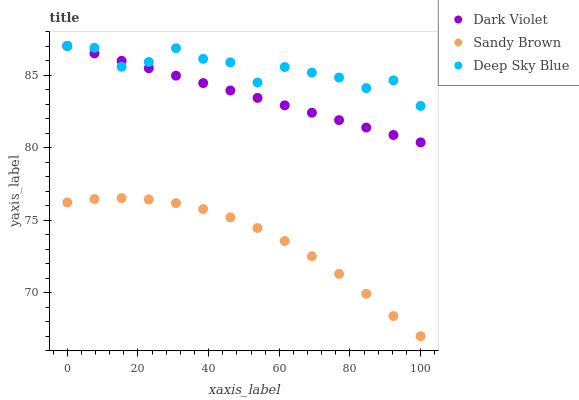Does Sandy Brown have the minimum area under the curve?
Answer yes or no. Yes. Does Deep Sky Blue have the maximum area under the curve?
Answer yes or no. Yes. Does Dark Violet have the minimum area under the curve?
Answer yes or no. No. Does Dark Violet have the maximum area under the curve?
Answer yes or no. No. Is Dark Violet the smoothest?
Answer yes or no. Yes. Is Deep Sky Blue the roughest?
Answer yes or no. Yes. Is Deep Sky Blue the smoothest?
Answer yes or no. No. Is Dark Violet the roughest?
Answer yes or no. No. Does Sandy Brown have the lowest value?
Answer yes or no. Yes. Does Dark Violet have the lowest value?
Answer yes or no. No. Does Dark Violet have the highest value?
Answer yes or no. Yes. Is Sandy Brown less than Deep Sky Blue?
Answer yes or no. Yes. Is Dark Violet greater than Sandy Brown?
Answer yes or no. Yes. Does Dark Violet intersect Deep Sky Blue?
Answer yes or no. Yes. Is Dark Violet less than Deep Sky Blue?
Answer yes or no. No. Is Dark Violet greater than Deep Sky Blue?
Answer yes or no. No. Does Sandy Brown intersect Deep Sky Blue?
Answer yes or no. No. 